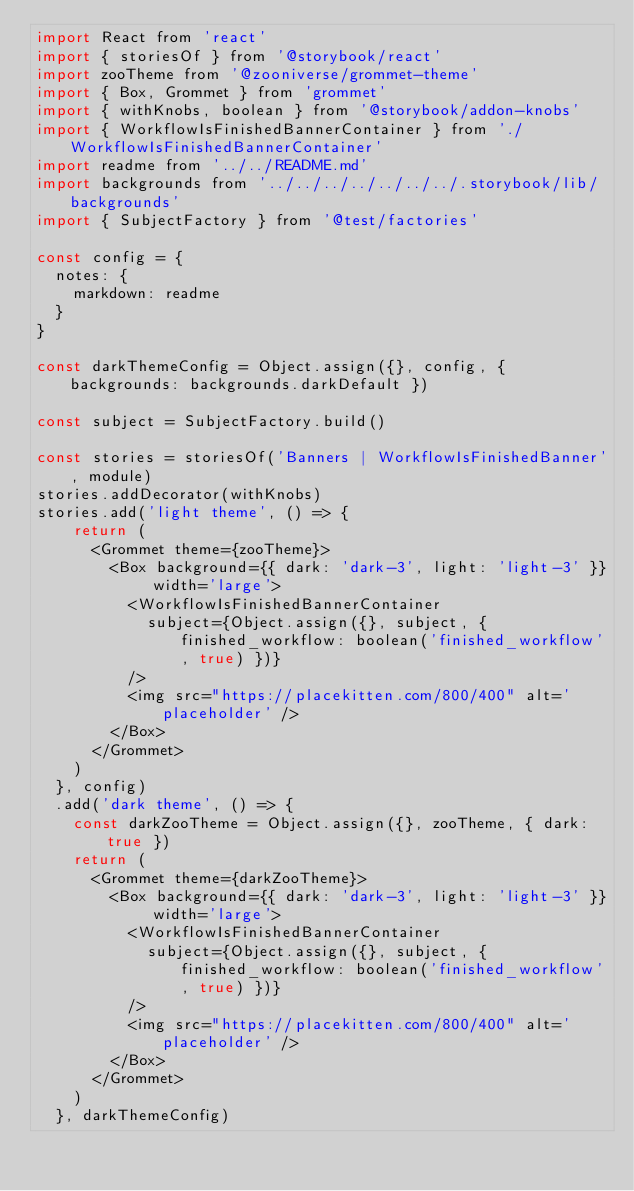Convert code to text. <code><loc_0><loc_0><loc_500><loc_500><_JavaScript_>import React from 'react'
import { storiesOf } from '@storybook/react'
import zooTheme from '@zooniverse/grommet-theme'
import { Box, Grommet } from 'grommet'
import { withKnobs, boolean } from '@storybook/addon-knobs'
import { WorkflowIsFinishedBannerContainer } from './WorkflowIsFinishedBannerContainer'
import readme from '../../README.md'
import backgrounds from '../../../../../../../.storybook/lib/backgrounds'
import { SubjectFactory } from '@test/factories'

const config = {
  notes: {
    markdown: readme
  }
}

const darkThemeConfig = Object.assign({}, config, { backgrounds: backgrounds.darkDefault })

const subject = SubjectFactory.build()

const stories = storiesOf('Banners | WorkflowIsFinishedBanner', module)
stories.addDecorator(withKnobs)
stories.add('light theme', () => {
    return (
      <Grommet theme={zooTheme}>
        <Box background={{ dark: 'dark-3', light: 'light-3' }} width='large'>
          <WorkflowIsFinishedBannerContainer
            subject={Object.assign({}, subject, { finished_workflow: boolean('finished_workflow', true) })}
          />
          <img src="https://placekitten.com/800/400" alt='placeholder' />
        </Box>
      </Grommet>
    )
  }, config)
  .add('dark theme', () => {
    const darkZooTheme = Object.assign({}, zooTheme, { dark: true })
    return (
      <Grommet theme={darkZooTheme}>
        <Box background={{ dark: 'dark-3', light: 'light-3' }} width='large'>
          <WorkflowIsFinishedBannerContainer
            subject={Object.assign({}, subject, { finished_workflow: boolean('finished_workflow', true) })}
          />
          <img src="https://placekitten.com/800/400" alt='placeholder' />
        </Box>
      </Grommet>
    )
  }, darkThemeConfig)
</code> 